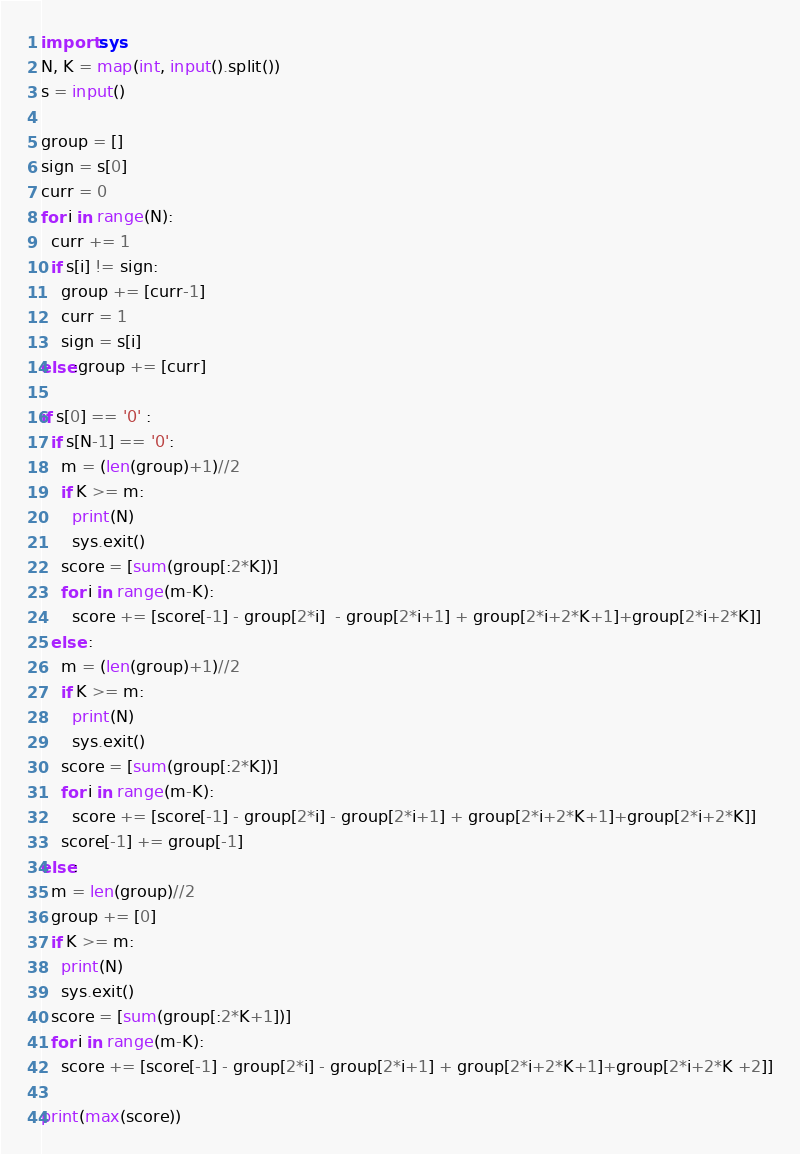Convert code to text. <code><loc_0><loc_0><loc_500><loc_500><_Python_>import sys
N, K = map(int, input().split())
s = input()
  
group = []
sign = s[0]
curr = 0
for i in range(N):
  curr += 1
  if s[i] != sign: 
    group += [curr-1]
    curr = 1
    sign = s[i]
else:group += [curr]

if s[0] == '0' :
  if s[N-1] == '0':
    m = (len(group)+1)//2
    if K >= m:
      print(N)
      sys.exit()
    score = [sum(group[:2*K])]
    for i in range(m-K):
      score += [score[-1] - group[2*i]  - group[2*i+1] + group[2*i+2*K+1]+group[2*i+2*K]]
  else :
    m = (len(group)+1)//2
    if K >= m:
      print(N)
      sys.exit()
    score = [sum(group[:2*K])]
    for i in range(m-K):
      score += [score[-1] - group[2*i] - group[2*i+1] + group[2*i+2*K+1]+group[2*i+2*K]]
    score[-1] += group[-1]
else:
  m = len(group)//2
  group += [0]
  if K >= m:
    print(N)
    sys.exit()
  score = [sum(group[:2*K+1])]
  for i in range(m-K):
    score += [score[-1] - group[2*i] - group[2*i+1] + group[2*i+2*K+1]+group[2*i+2*K +2]]

print(max(score))</code> 